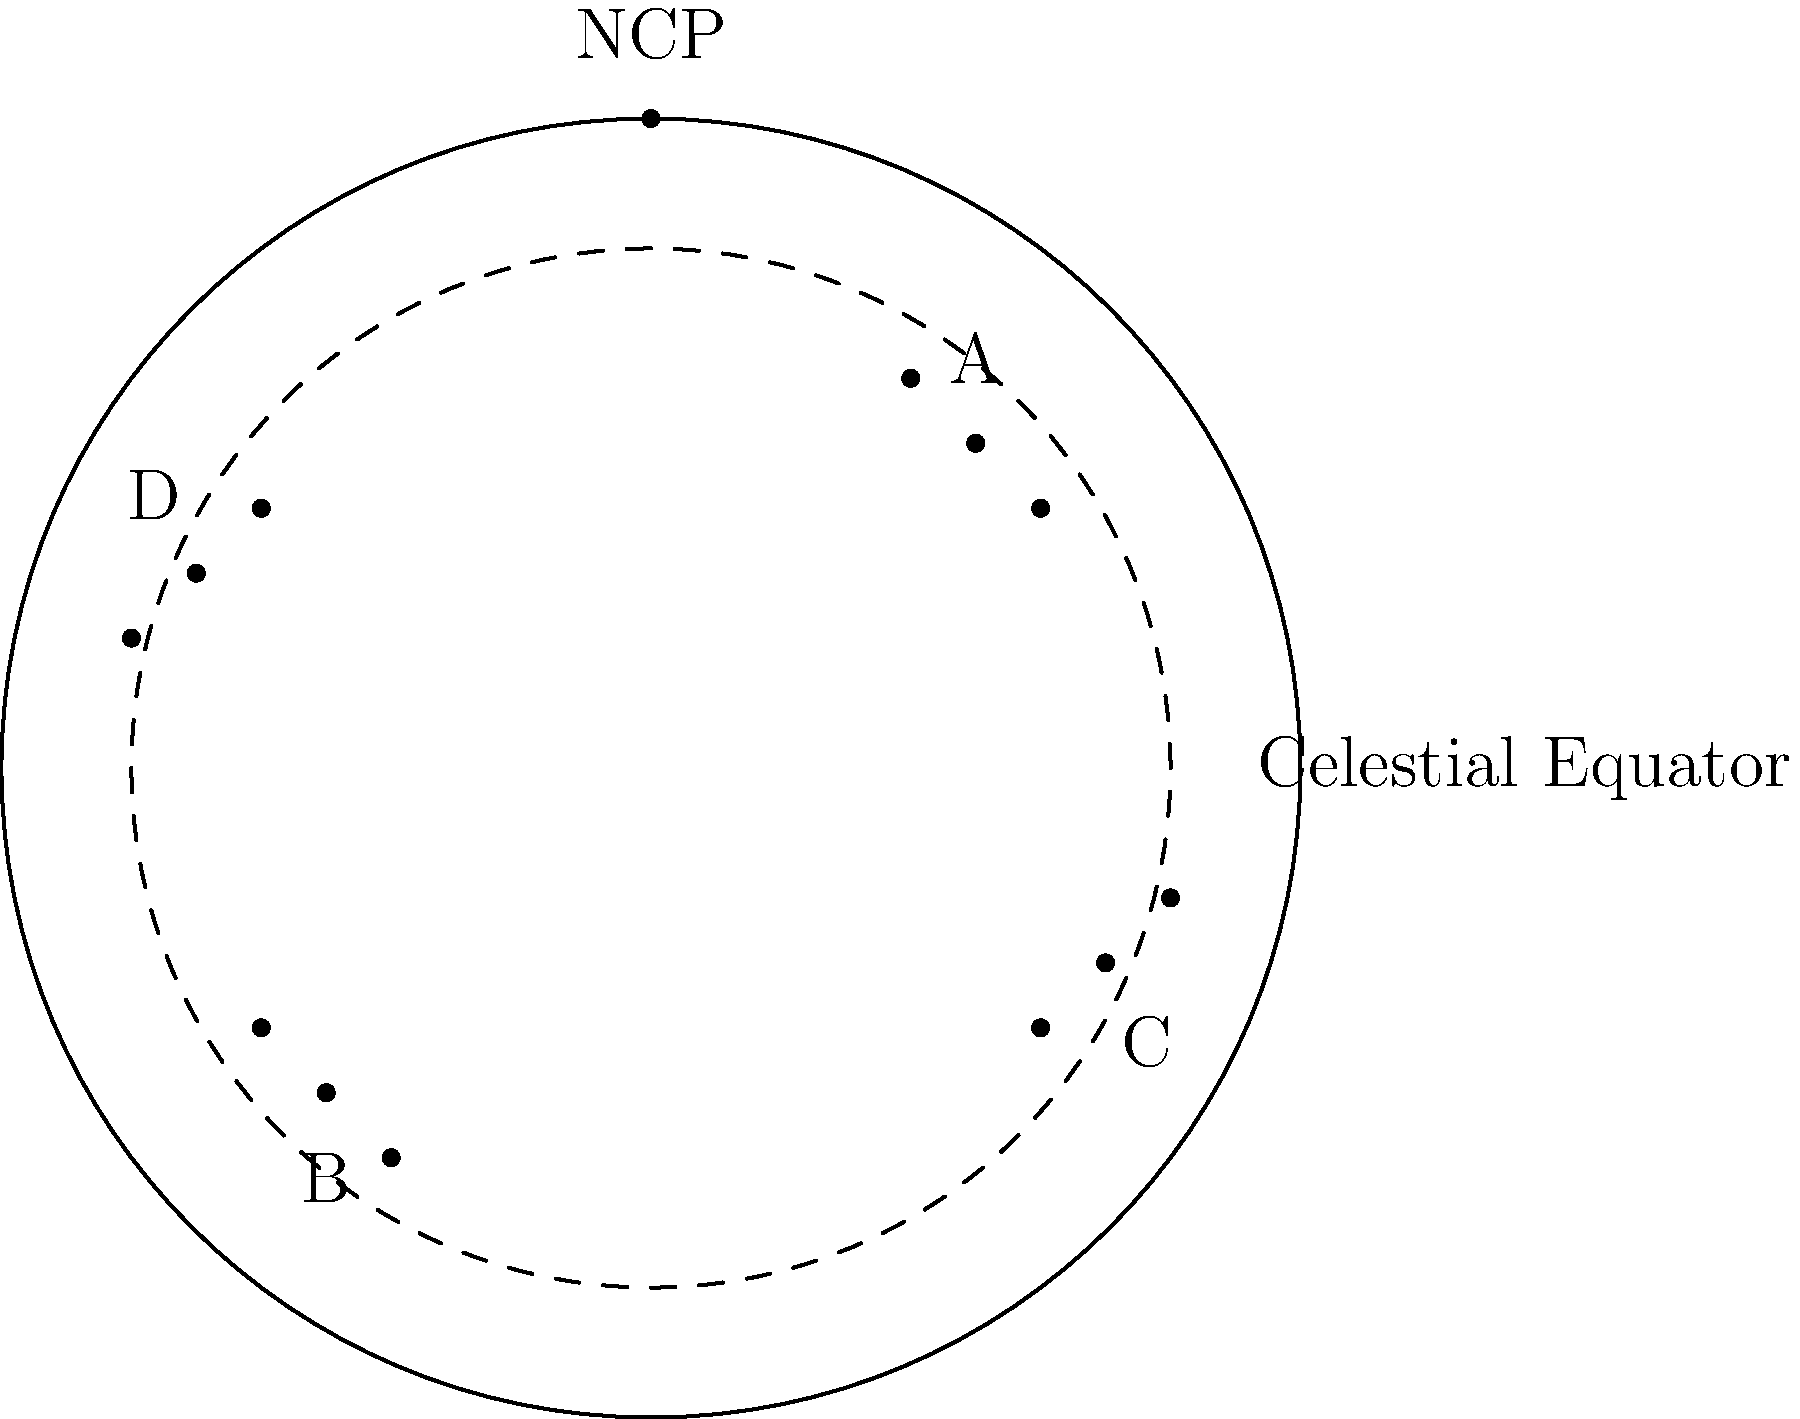As a coach who has traveled for international competitions, you've developed an interest in navigating by the stars. In the star chart above, which constellation is closest to the North Celestial Pole (NCP)? To determine which constellation is closest to the North Celestial Pole (NCP), we need to follow these steps:

1. Identify the NCP on the star chart:
   The NCP is labeled and located at the top of the circular chart.

2. Identify the constellations:
   There are four constellations labeled A, B, C, and D on the chart.

3. Assess the position of each constellation relative to the NCP:
   A: Located in the upper right quadrant
   B: Located in the lower left quadrant
   C: Located in the lower right quadrant
   D: Located in the upper left quadrant

4. Compare the distances:
   Visually, we can see that constellation A is the closest to the NCP.

5. Consider the celestial sphere:
   The closer a constellation is to the NCP, the less it appears to move in the night sky from our perspective on Earth. This makes circumpolar constellations useful for navigation.

Given the positions on the chart, constellation A is clearly the closest to the NCP and would be the most useful for navigation in the northern hemisphere.
Answer: A 